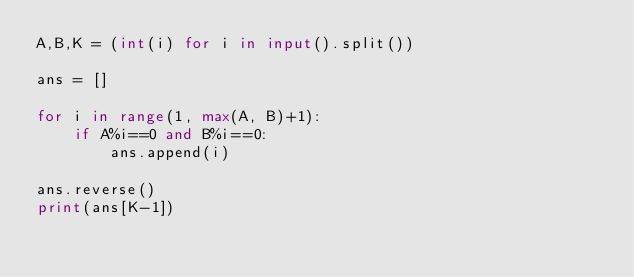<code> <loc_0><loc_0><loc_500><loc_500><_Python_>A,B,K = (int(i) for i in input().split())  

ans = []

for i in range(1, max(A, B)+1):
	if A%i==0 and B%i==0:
		ans.append(i)

ans.reverse()
print(ans[K-1])</code> 